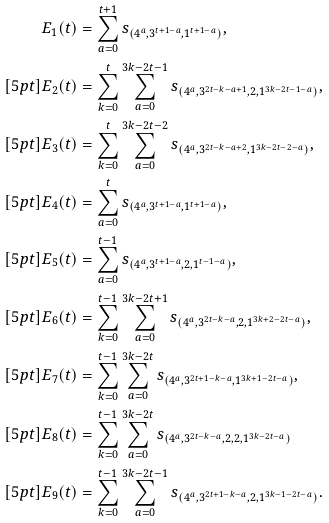Convert formula to latex. <formula><loc_0><loc_0><loc_500><loc_500>E _ { 1 } ( t ) & = \sum _ { a = 0 } ^ { t + 1 } s _ { ( 4 ^ { a } , 3 ^ { t + 1 - a } , 1 ^ { t + 1 - a } ) } , \\ [ 5 p t ] E _ { 2 } ( t ) & = \sum _ { k = 0 } ^ { t } \sum _ { a = 0 } ^ { 3 k - 2 t - 1 } s _ { ( 4 ^ { a } , 3 ^ { 2 t - k - a + 1 } , 2 , 1 ^ { 3 k - 2 t - 1 - a } ) } , \\ [ 5 p t ] E _ { 3 } ( t ) & = \sum _ { k = 0 } ^ { t } \sum _ { a = 0 } ^ { 3 k - 2 t - 2 } s _ { ( 4 ^ { a } , 3 ^ { 2 t - k - a + 2 } , 1 ^ { 3 k - 2 t - 2 - a } ) } , \\ [ 5 p t ] E _ { 4 } ( t ) & = \sum _ { a = 0 } ^ { t } s _ { ( 4 ^ { a } , 3 ^ { t + 1 - a } , 1 ^ { t + 1 - a } ) } , \\ [ 5 p t ] E _ { 5 } ( t ) & = \sum _ { a = 0 } ^ { t - 1 } s _ { ( 4 ^ { a } , 3 ^ { t + 1 - a } , 2 , 1 ^ { t - 1 - a } ) } , \\ [ 5 p t ] E _ { 6 } ( t ) & = \sum _ { k = 0 } ^ { t - 1 } \sum _ { a = 0 } ^ { 3 k - 2 t + 1 } s _ { ( 4 ^ { a } , 3 ^ { 2 t - k - a } , 2 , 1 ^ { 3 k + 2 - 2 t - a } ) } , \\ [ 5 p t ] E _ { 7 } ( t ) & = \sum _ { k = 0 } ^ { t - 1 } \sum _ { a = 0 } ^ { 3 k - 2 t } s _ { ( 4 ^ { a } , 3 ^ { 2 t + 1 - k - a } , 1 ^ { 3 k + 1 - 2 t - a } ) } , \\ [ 5 p t ] E _ { 8 } ( t ) & = \sum _ { k = 0 } ^ { t - 1 } \sum _ { a = 0 } ^ { 3 k - 2 t } s _ { ( 4 ^ { a } , 3 ^ { 2 t - k - a } , 2 , 2 , 1 ^ { 3 k - 2 t - a } ) } \\ [ 5 p t ] E _ { 9 } ( t ) & = \sum _ { k = 0 } ^ { t - 1 } \sum _ { a = 0 } ^ { 3 k - 2 t - 1 } s _ { ( 4 ^ { a } , 3 ^ { 2 t + 1 - k - a } , 2 , 1 ^ { 3 k - 1 - 2 t - a } ) } .</formula> 